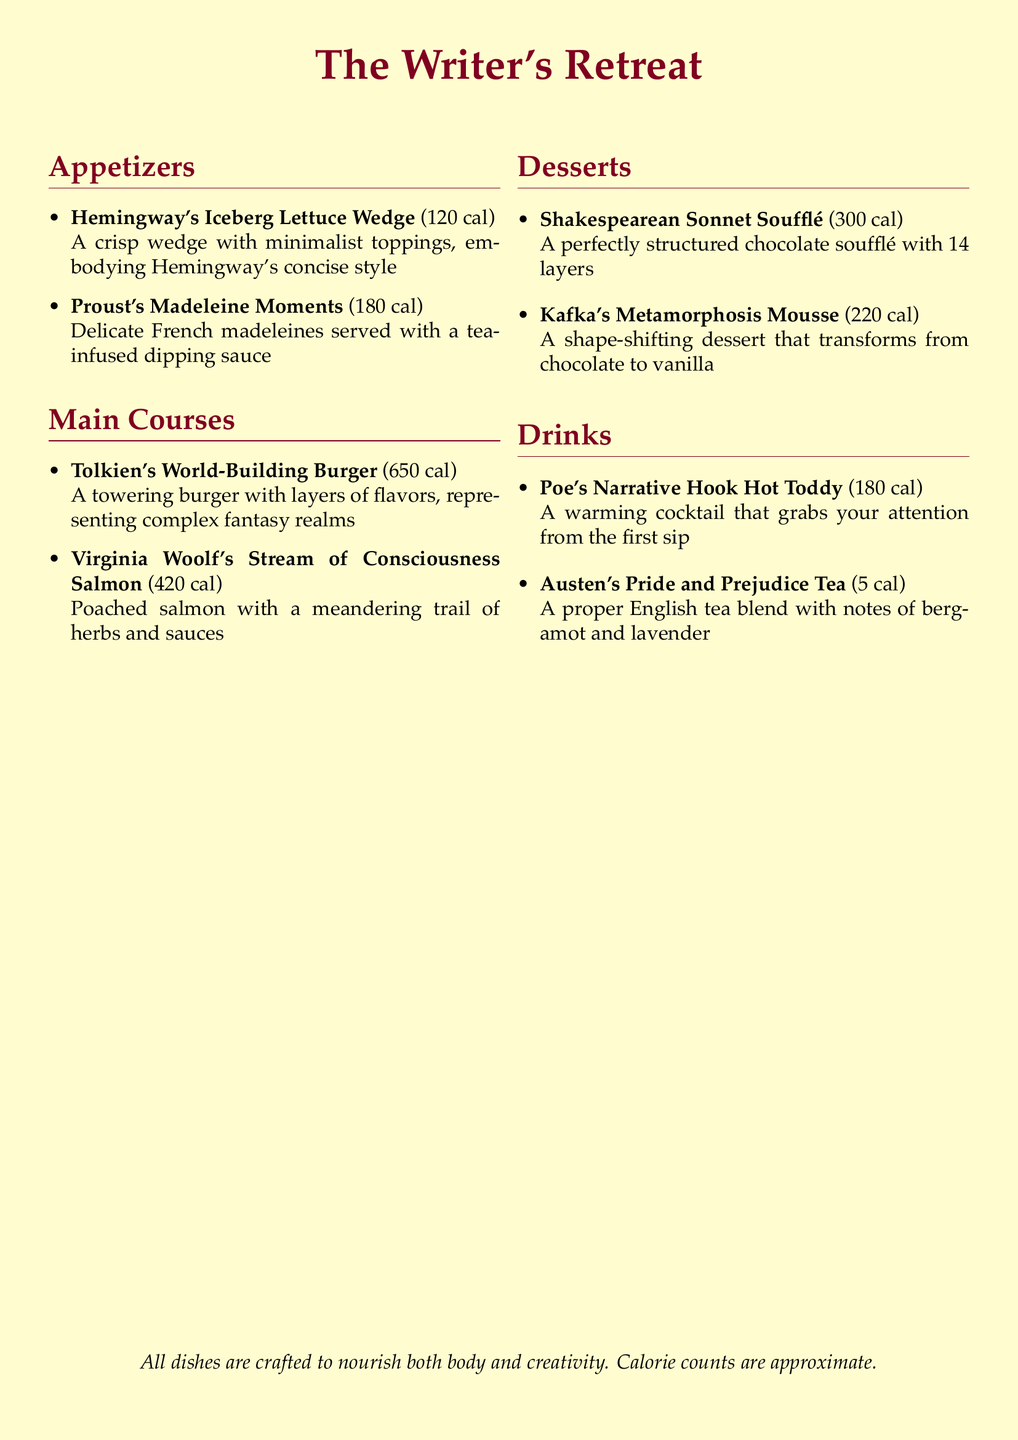What is the calorie count for Hemingway's Iceberg Lettuce Wedge? The calorie count for Hemingway's Iceberg Lettuce Wedge is specified in the menu.
Answer: 120 cal What dish represents Virginia Woolf's writing style? The dish that represents Virginia Woolf's writing style is mentioned in the menu.
Answer: Virginia Woolf's Stream of Consciousness Salmon How many layers does the Shakespearean Sonnet Soufflé have? The layers of the Shakespearean Sonnet Soufflé are detailed in the menu description.
Answer: 14 layers Which dessert transforms from chocolate to vanilla? The dessert that transforms from chocolate to vanilla is named in the dessert section of the menu.
Answer: Kafka's Metamorphosis Mousse What kind of drink is Austen's Pride and Prejudice Tea? The type of drink is described in the menu, including its calorie count.
Answer: English tea What is the calorie count for the Proust's Madeleine Moments? The calorie count for Proust's Madeleine Moments can be found in the appetizers section of the menu.
Answer: 180 cal Which dish includes a warming cocktail? The dish that includes a warming cocktail is found in the drinks section of the menu.
Answer: Poe's Narrative Hook Hot Toddy What type of dish is the Tolkien's World-Building Burger? The type of dish is categorized in the main courses of the menu.
Answer: Burger What is the main ingredient in Virginia Woolf's dish? The main ingredient of Virginia Woolf's dish is provided in the description of the main courses.
Answer: Salmon 